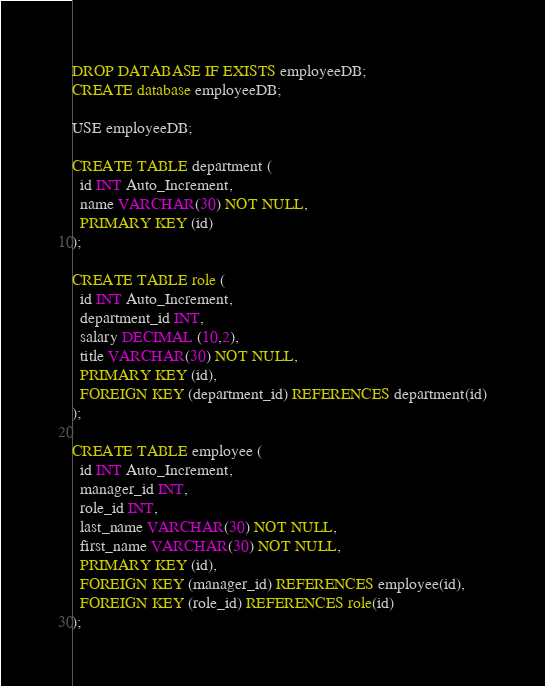<code> <loc_0><loc_0><loc_500><loc_500><_SQL_>DROP DATABASE IF EXISTS employeeDB;
CREATE database employeeDB;

USE employeeDB;

CREATE TABLE department (
  id INT Auto_Increment,
  name VARCHAR(30) NOT NULL,
  PRIMARY KEY (id)
);

CREATE TABLE role (
  id INT Auto_Increment,
  department_id INT, 
  salary DECIMAL (10,2),
  title VARCHAR(30) NOT NULL,
  PRIMARY KEY (id),
  FOREIGN KEY (department_id) REFERENCES department(id)
);

CREATE TABLE employee (
  id INT Auto_Increment,
  manager_id INT,
  role_id INT,
  last_name VARCHAR(30) NOT NULL,
  first_name VARCHAR(30) NOT NULL,
  PRIMARY KEY (id),
  FOREIGN KEY (manager_id) REFERENCES employee(id),
  FOREIGN KEY (role_id) REFERENCES role(id)
);</code> 